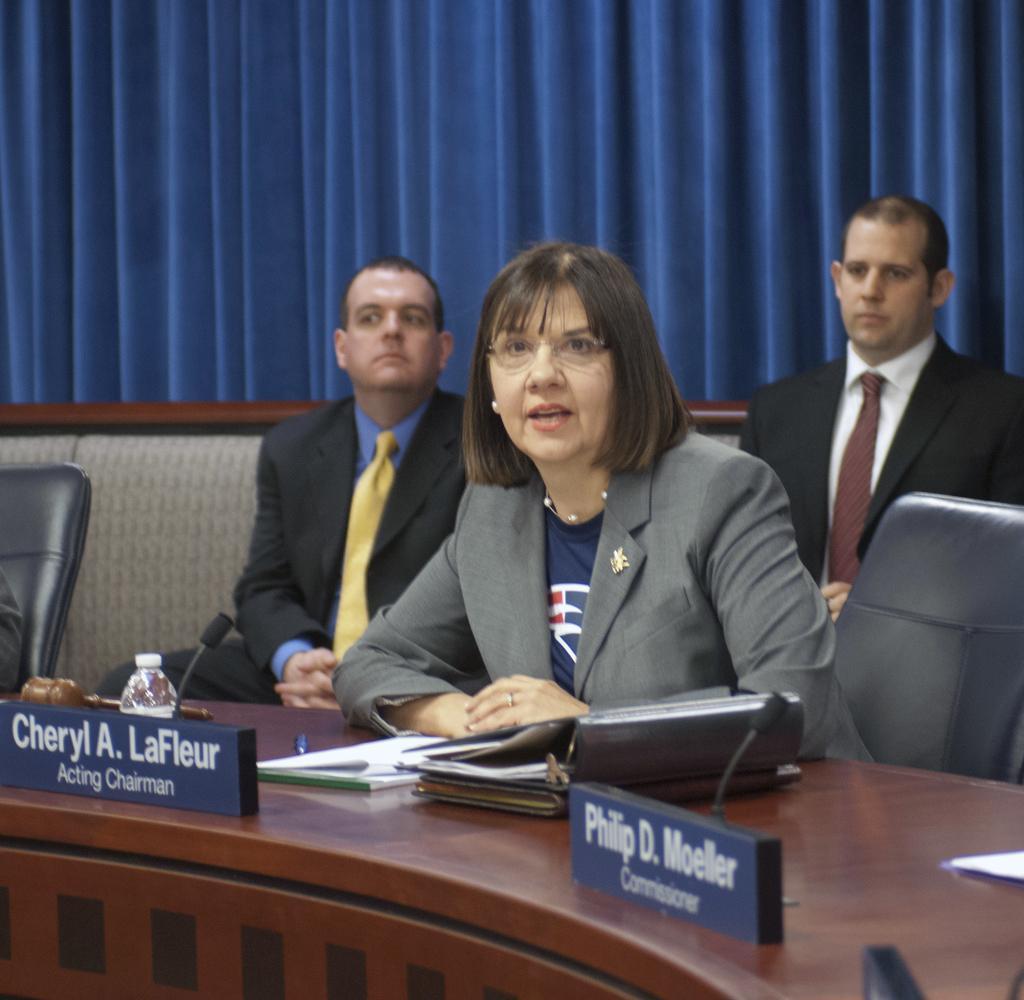Can you describe this image briefly? In this image there are three persons sitting on to the chairs in middle of this image and there is a blue color curtain on top of this image. There is a table on bottom of this image and there are some objects kept on it. 